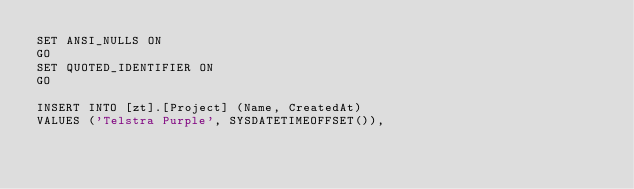<code> <loc_0><loc_0><loc_500><loc_500><_SQL_>SET ANSI_NULLS ON
GO
SET QUOTED_IDENTIFIER ON
GO

INSERT INTO [zt].[Project] (Name, CreatedAt)
VALUES ('Telstra Purple', SYSDATETIMEOFFSET()),</code> 